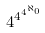Convert formula to latex. <formula><loc_0><loc_0><loc_500><loc_500>4 ^ { 4 ^ { 4 ^ { \aleph _ { 0 } } } }</formula> 